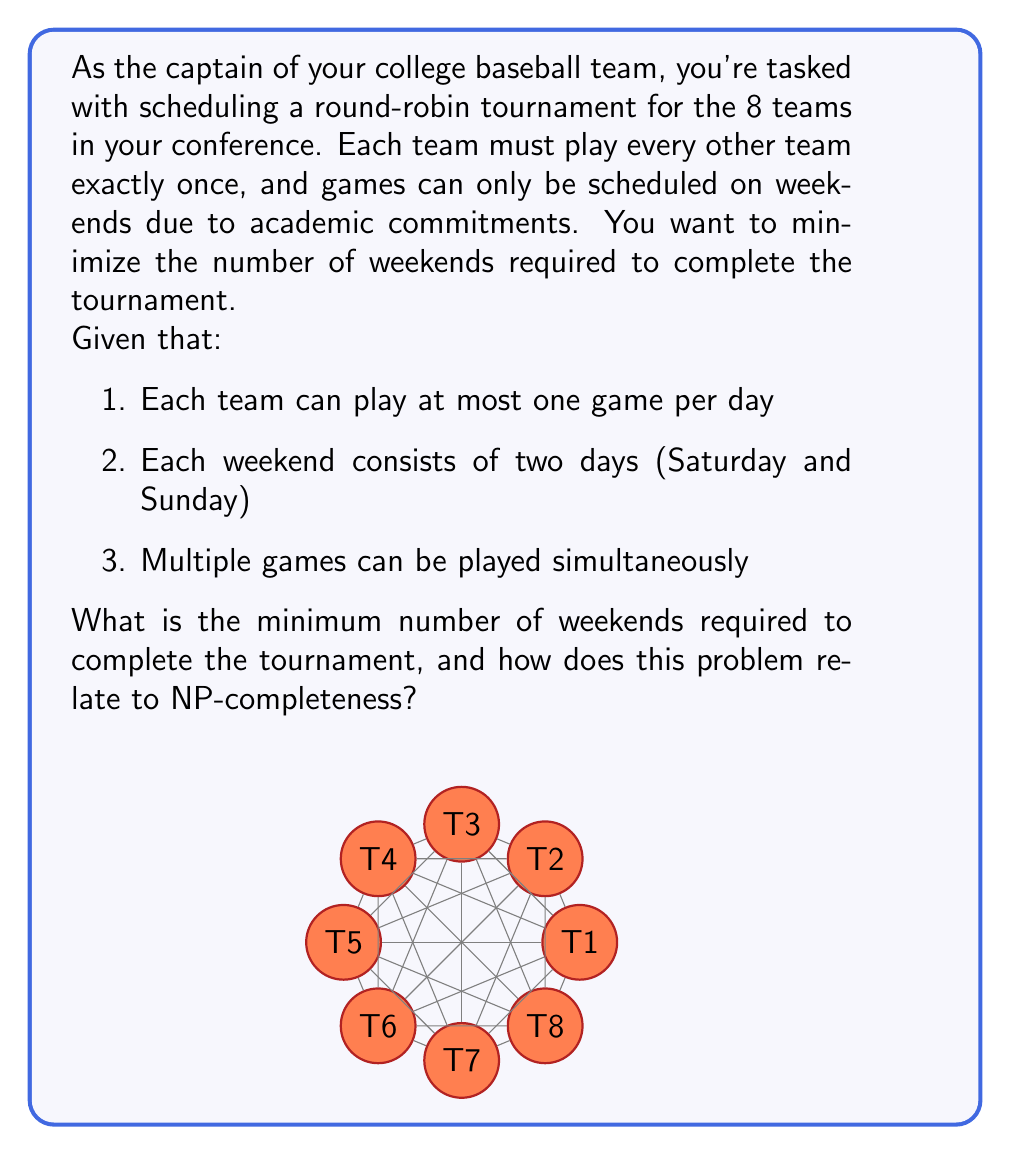Give your solution to this math problem. Let's approach this step-by-step:

1) First, we need to calculate the total number of games in the tournament:
   With 8 teams, each team plays 7 others once.
   Total games = $\frac{8 \times 7}{2} = 28$ games

2) Now, let's consider how many games can be played each weekend:
   - Each day, we can have at most 4 games (8 teams / 2 teams per game)
   - Each weekend has 2 days
   So, maximum games per weekend = $4 \times 2 = 8$ games

3) Dividing total games by games per weekend:
   $\frac{28}{8} = 3.5$
   This means we need at least 4 weekends.

4) To prove 4 weekends is actually achievable, we could construct a schedule. However, finding such a schedule is not trivial, which leads us to the NP-completeness aspect.

5) This problem is closely related to the "Graph Coloring Problem", which is known to be NP-complete:
   - Each team can be represented as a vertex in a graph
   - Each game can be represented as an edge
   - Each time slot (day) can be represented as a color

6) The challenge of finding the minimum number of colors (time slots) needed to color the edges of the graph, such that no two edges of the same color are incident on the same vertex, is equivalent to our scheduling problem.

7) While we can easily verify if a given schedule is valid and uses the minimum number of weekends (polynomial time), finding such a schedule becomes increasingly difficult as the number of teams grows (exponential time in the worst case).

8) This property of being easy to verify but potentially hard to solve is characteristic of NP-complete problems.

Thus, this sports scheduling problem demonstrates key aspects of NP-completeness: it's in NP (easily verifiable), and it's at least as hard as other known NP-complete problems (reducible from Graph Coloring).
Answer: 4 weekends; it's NP-complete due to equivalence with Edge Coloring Problem. 